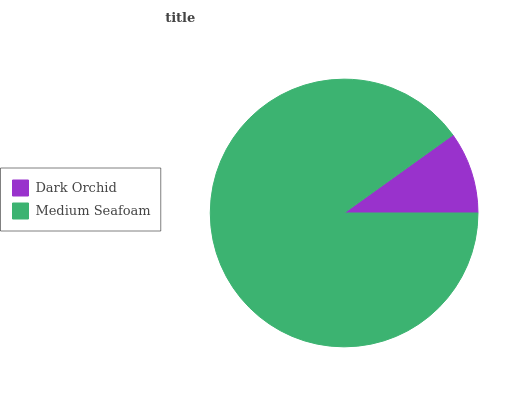Is Dark Orchid the minimum?
Answer yes or no. Yes. Is Medium Seafoam the maximum?
Answer yes or no. Yes. Is Medium Seafoam the minimum?
Answer yes or no. No. Is Medium Seafoam greater than Dark Orchid?
Answer yes or no. Yes. Is Dark Orchid less than Medium Seafoam?
Answer yes or no. Yes. Is Dark Orchid greater than Medium Seafoam?
Answer yes or no. No. Is Medium Seafoam less than Dark Orchid?
Answer yes or no. No. Is Medium Seafoam the high median?
Answer yes or no. Yes. Is Dark Orchid the low median?
Answer yes or no. Yes. Is Dark Orchid the high median?
Answer yes or no. No. Is Medium Seafoam the low median?
Answer yes or no. No. 